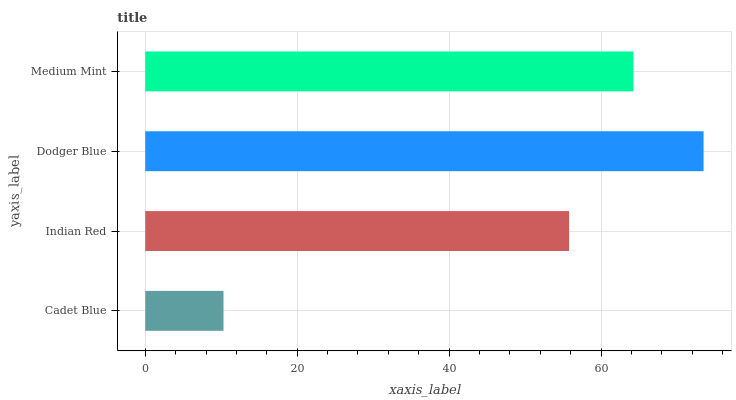Is Cadet Blue the minimum?
Answer yes or no. Yes. Is Dodger Blue the maximum?
Answer yes or no. Yes. Is Indian Red the minimum?
Answer yes or no. No. Is Indian Red the maximum?
Answer yes or no. No. Is Indian Red greater than Cadet Blue?
Answer yes or no. Yes. Is Cadet Blue less than Indian Red?
Answer yes or no. Yes. Is Cadet Blue greater than Indian Red?
Answer yes or no. No. Is Indian Red less than Cadet Blue?
Answer yes or no. No. Is Medium Mint the high median?
Answer yes or no. Yes. Is Indian Red the low median?
Answer yes or no. Yes. Is Dodger Blue the high median?
Answer yes or no. No. Is Cadet Blue the low median?
Answer yes or no. No. 